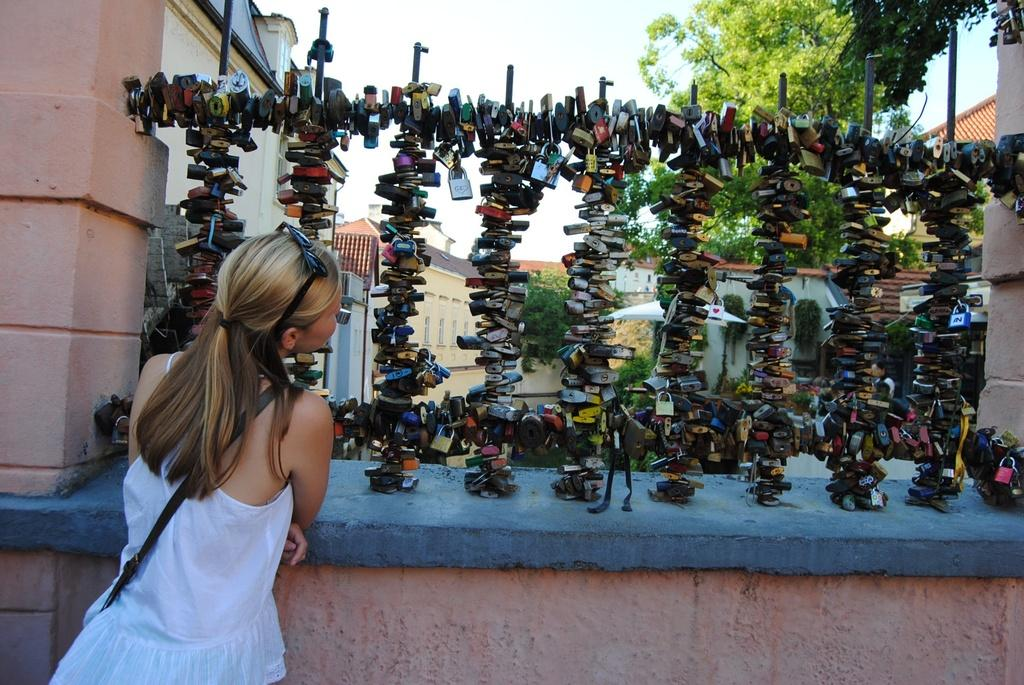What is attached to the stand on the wall in the image? The objects attached to the stand on the wall are not specified in the facts provided. What is the girl in the image wearing? The girl in the image is wearing goggles. What is the girl holding in the image? The girl is holding a bag. What type of natural environment is visible in the image? Trees are visible in the image. What type of man-made structures are visible in the image? Buildings are visible in the image. What is the girl's reaction to the trick in the image? There is no trick or reaction mentioned in the image. How many objects are attached to the stand on the wall in the image? The number of objects attached to the stand on the wall is not specified in the facts provided. 